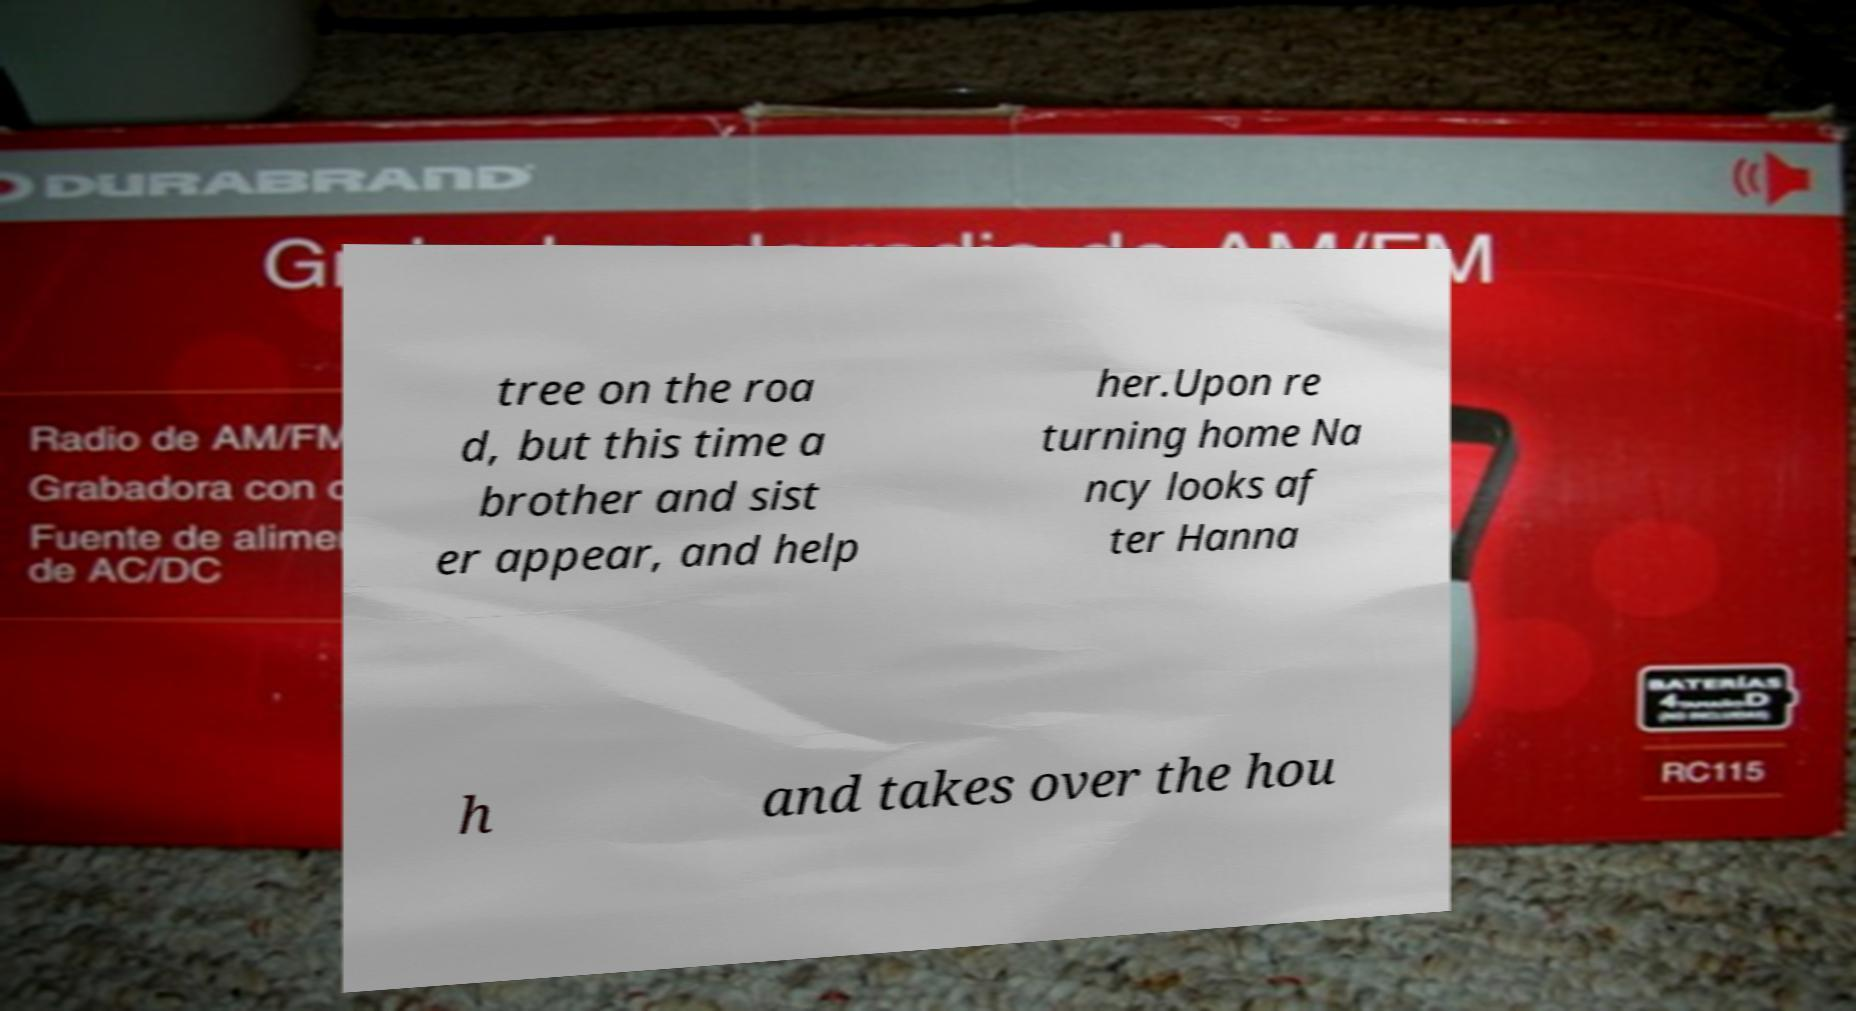Can you read and provide the text displayed in the image?This photo seems to have some interesting text. Can you extract and type it out for me? tree on the roa d, but this time a brother and sist er appear, and help her.Upon re turning home Na ncy looks af ter Hanna h and takes over the hou 